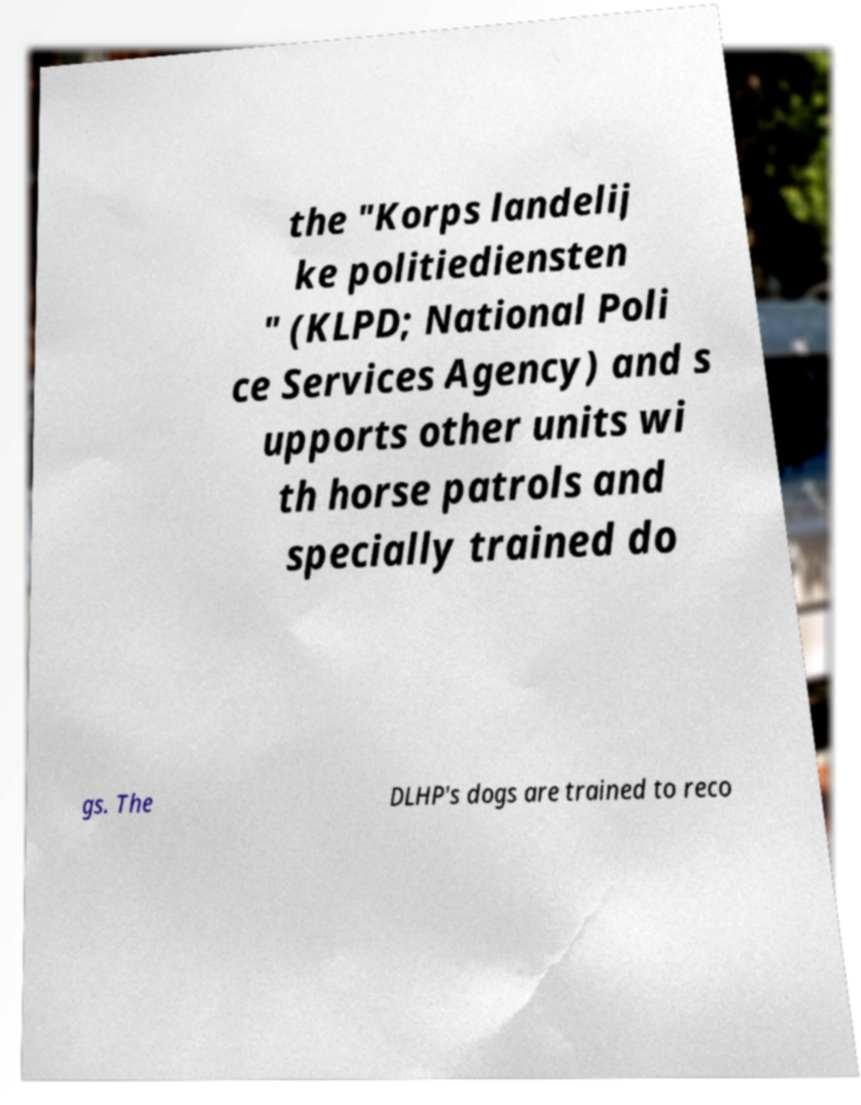Could you extract and type out the text from this image? the "Korps landelij ke politiediensten " (KLPD; National Poli ce Services Agency) and s upports other units wi th horse patrols and specially trained do gs. The DLHP's dogs are trained to reco 